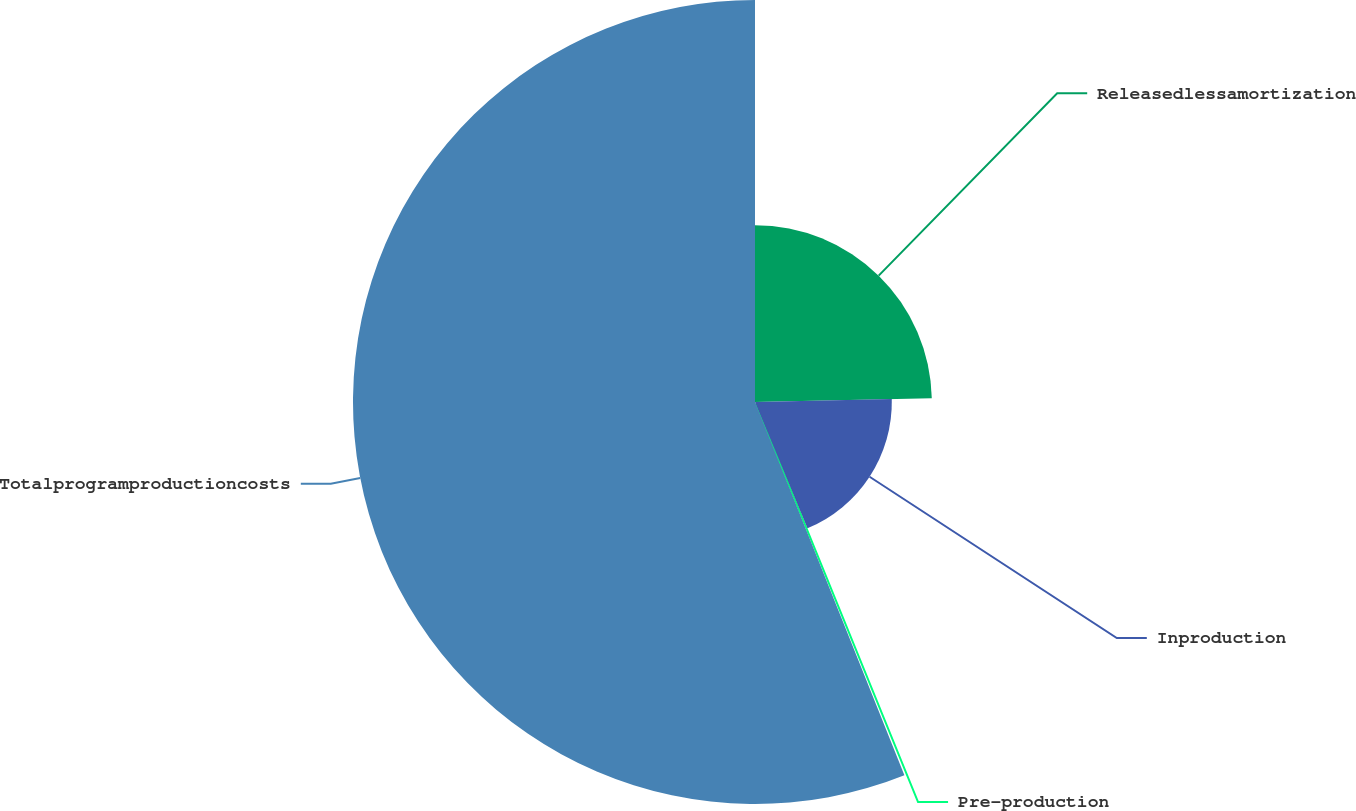<chart> <loc_0><loc_0><loc_500><loc_500><pie_chart><fcel>Releasedlessamortization<fcel>Inproduction<fcel>Pre-production<fcel>Totalprogramproductioncosts<nl><fcel>24.66%<fcel>19.08%<fcel>0.2%<fcel>56.06%<nl></chart> 